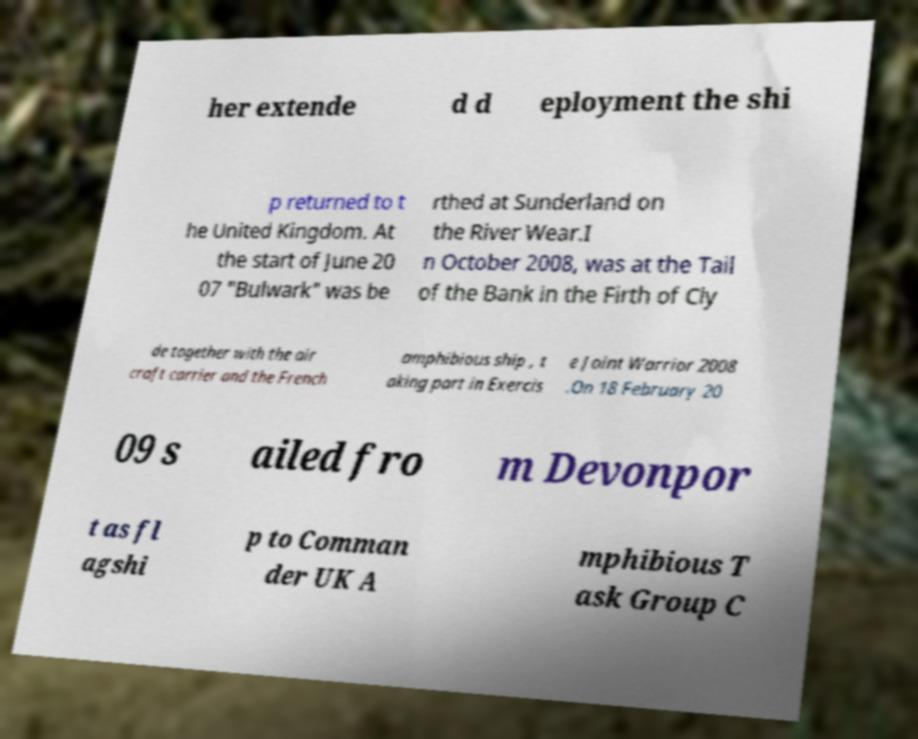Can you read and provide the text displayed in the image?This photo seems to have some interesting text. Can you extract and type it out for me? her extende d d eployment the shi p returned to t he United Kingdom. At the start of June 20 07 "Bulwark" was be rthed at Sunderland on the River Wear.I n October 2008, was at the Tail of the Bank in the Firth of Cly de together with the air craft carrier and the French amphibious ship , t aking part in Exercis e Joint Warrior 2008 .On 18 February 20 09 s ailed fro m Devonpor t as fl agshi p to Comman der UK A mphibious T ask Group C 